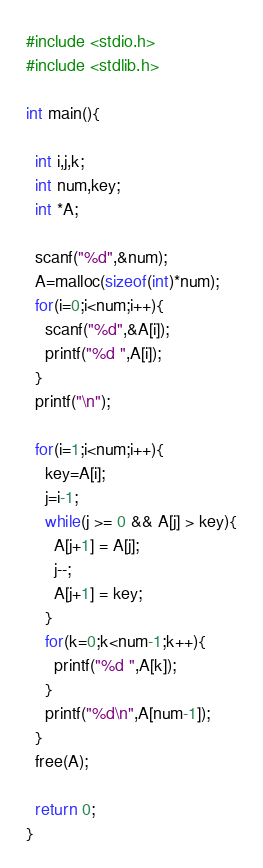<code> <loc_0><loc_0><loc_500><loc_500><_C_>#include <stdio.h>
#include <stdlib.h>

int main(){

  int i,j,k;
  int num,key;
  int *A;
  
  scanf("%d",&num);
  A=malloc(sizeof(int)*num);
  for(i=0;i<num;i++){
    scanf("%d",&A[i]);
    printf("%d ",A[i]);
  }
  printf("\n");

  for(i=1;i<num;i++){
    key=A[i];
    j=i-1;
    while(j >= 0 && A[j] > key){
      A[j+1] = A[j]; 
      j--;
      A[j+1] = key;
    }
    for(k=0;k<num-1;k++){
      printf("%d ",A[k]);
    }
    printf("%d\n",A[num-1]);
  }
  free(A);
  
  return 0;
}</code> 